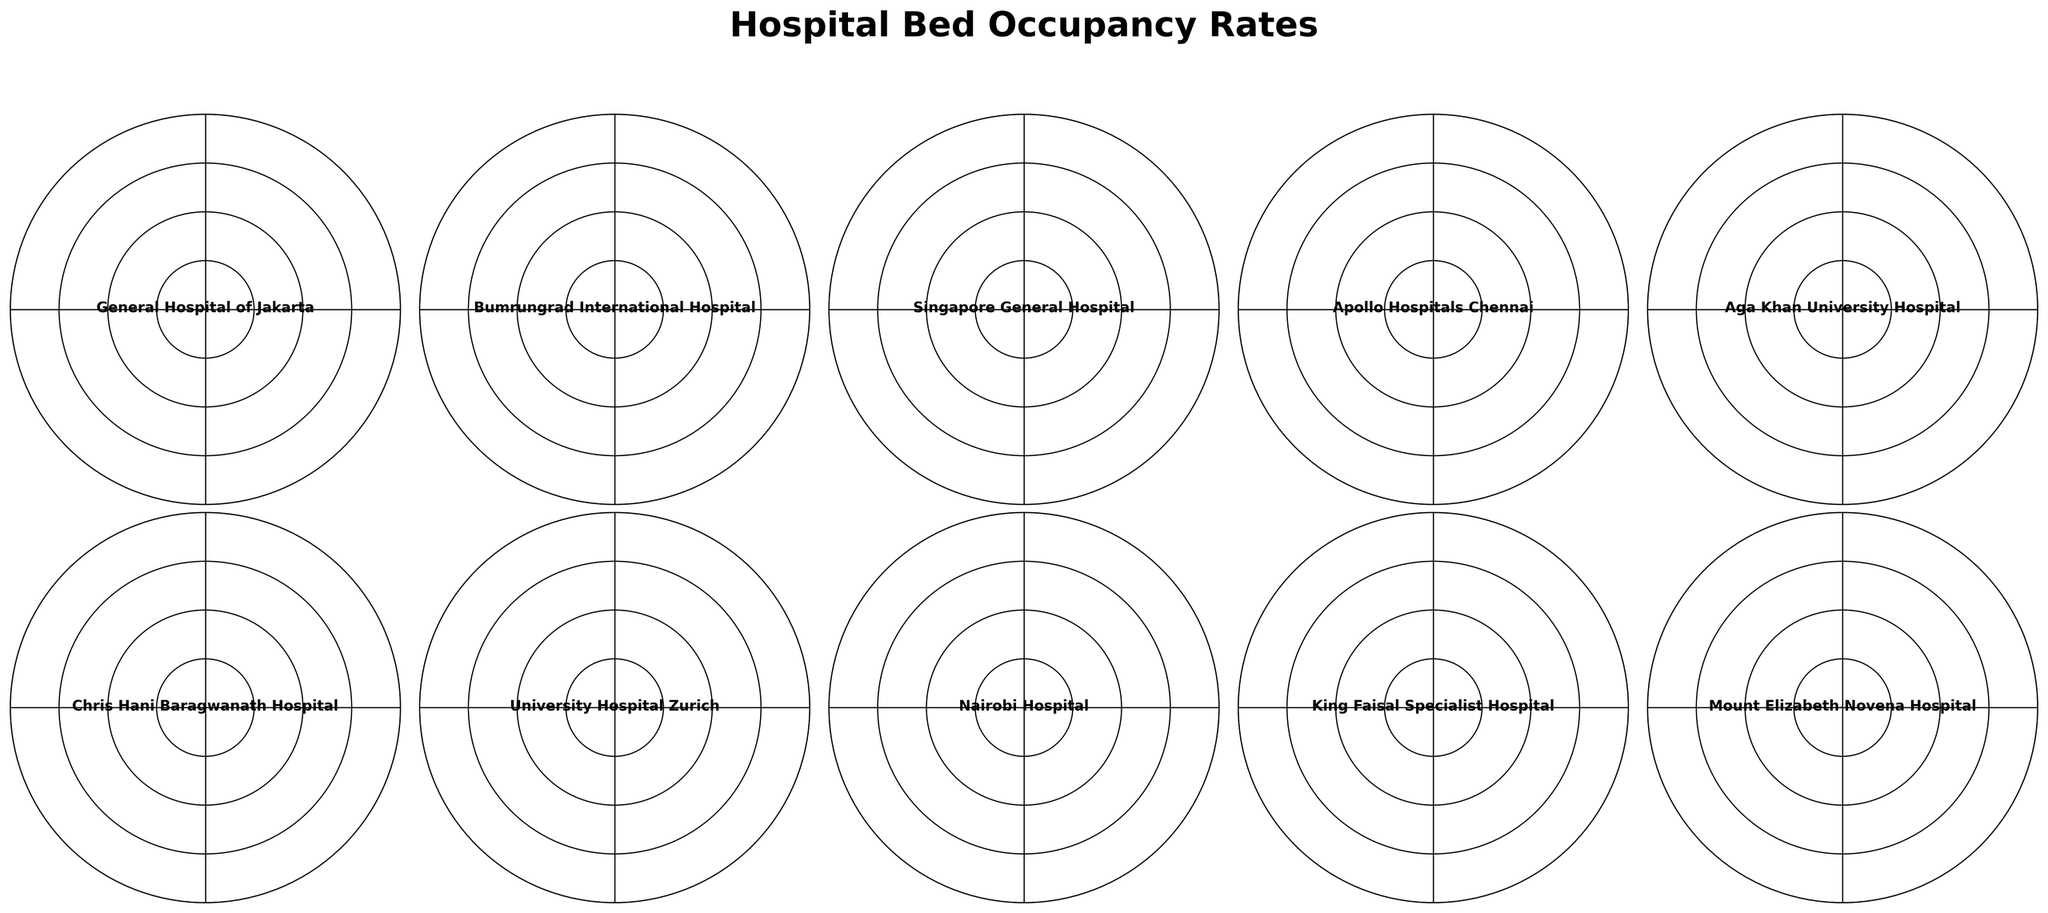What is the title of the figure? The title of the figure is usually located at the top and gives an overview of what the plot is about. In this case, it should be clearly visible above the gauges.
Answer: Hospital Bed Occupancy Rates How many hospitals are represented in the figure? To determine the number of hospitals represented, count the individual gauge charts shown in the figure.
Answer: 10 Which hospital has the highest bed occupancy rate? Look for the gauge where the arrow is closest to the maximum percentage (100%).
Answer: Chris Hani Baragwanath Hospital Which hospital has the lowest bed occupancy rate? Identify the gauge where the arrow is closest to the minimum percentage (0%).
Answer: Nairobi Hospital What are the three color segments in each gauge supposed to represent? The gauge segments typically use colors to represent different ranges of occupancy. Determine the value ranges indicated by each color from context. For example, red might indicate high occupancy, yellow medium, and green low.
Answer: Red (0-33.3%), Yellow (33.3-66.6%), Green (66.6-100%) How does the bed occupancy rate of General Hospital of Jakarta compare to that of Mount Elizabeth Novena Hospital? Compare the percentage values shown in the gauge charts of both hospitals to determine which is higher or if they are equal.
Answer: General Hospital of Jakarta (78.5%) is lower than Mount Elizabeth Novena Hospital (79.8%) What is the range of bed occupancy rates among the hospitals? To find the range, identify the highest and the lowest bed occupancy rates, then subtract the lowest from the highest.
Answer: 95.7% - 72.9% = 22.8% Which hospital has a bed occupancy rate closest to the average rate of all hospitals shown? First calculate the average occupancy rate of all hospitals. Then, find the hospital whose occupancy rate is closest to this average. The calculations are: (78.5 + 85.2 + 92.1 + 76.8 + 81.3 + 95.7 + 88.4 + 72.9 + 83.6 + 79.8) / 10 = 83.43%. Now find the hospital with the occupancy rate nearest to 83.43%.
Answer: King Faisal Specialist Hospital (83.6%) Which hospitals have occupancy rates in the red zone? Identify the gauges where the arrows fall within the red segment of the gauge, suggesting high bed occupancy rates. Typically the red zone might be the highest segment, which is likely 66.6-100%
Answer: Chris Hani Baragwanath Hospital, Singapore General Hospital, University Hospital Zurich What patterns or trends can be observed across the hospitals' bed occupancy rates? Observe the positions of the arrows across all gauge charts to identify any commonalities or notable differences. For instance, more arrows in the green or yellow zone would indicate most hospitals have medium to high occupancy.
Answer: Most hospitals have occupancy rates in the green zone, indicating generally high bed occupancy rates across various healthcare facilities 